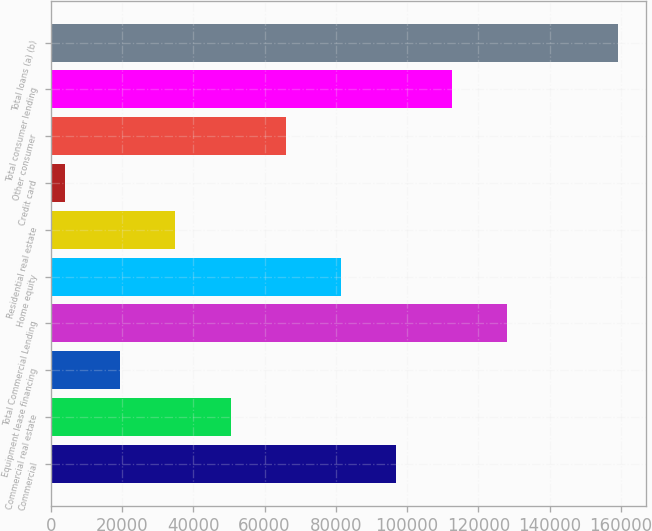<chart> <loc_0><loc_0><loc_500><loc_500><bar_chart><fcel>Commercial<fcel>Commercial real estate<fcel>Equipment lease financing<fcel>Total Commercial Lending<fcel>Home equity<fcel>Residential real estate<fcel>Credit card<fcel>Other consumer<fcel>Total consumer lending<fcel>Total loans (a) (b)<nl><fcel>96998.8<fcel>50487.4<fcel>19479.8<fcel>128006<fcel>81495<fcel>34983.6<fcel>3976<fcel>65991.2<fcel>112503<fcel>159014<nl></chart> 